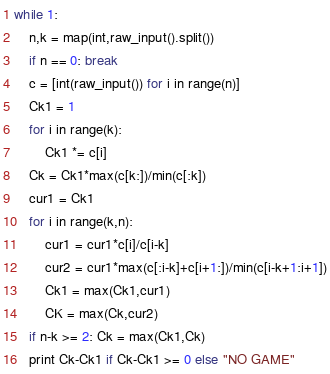<code> <loc_0><loc_0><loc_500><loc_500><_Python_>while 1:
	n,k = map(int,raw_input().split())
	if n == 0: break
	c = [int(raw_input()) for i in range(n)]
	Ck1 = 1
	for i in range(k):
		Ck1 *= c[i]
	Ck = Ck1*max(c[k:])/min(c[:k])
	cur1 = Ck1
	for i in range(k,n):
		cur1 = cur1*c[i]/c[i-k]
		cur2 = cur1*max(c[:i-k]+c[i+1:])/min(c[i-k+1:i+1])
		Ck1 = max(Ck1,cur1)
		CK = max(Ck,cur2)
	if n-k >= 2: Ck = max(Ck1,Ck)
	print Ck-Ck1 if Ck-Ck1 >= 0 else "NO GAME"	</code> 